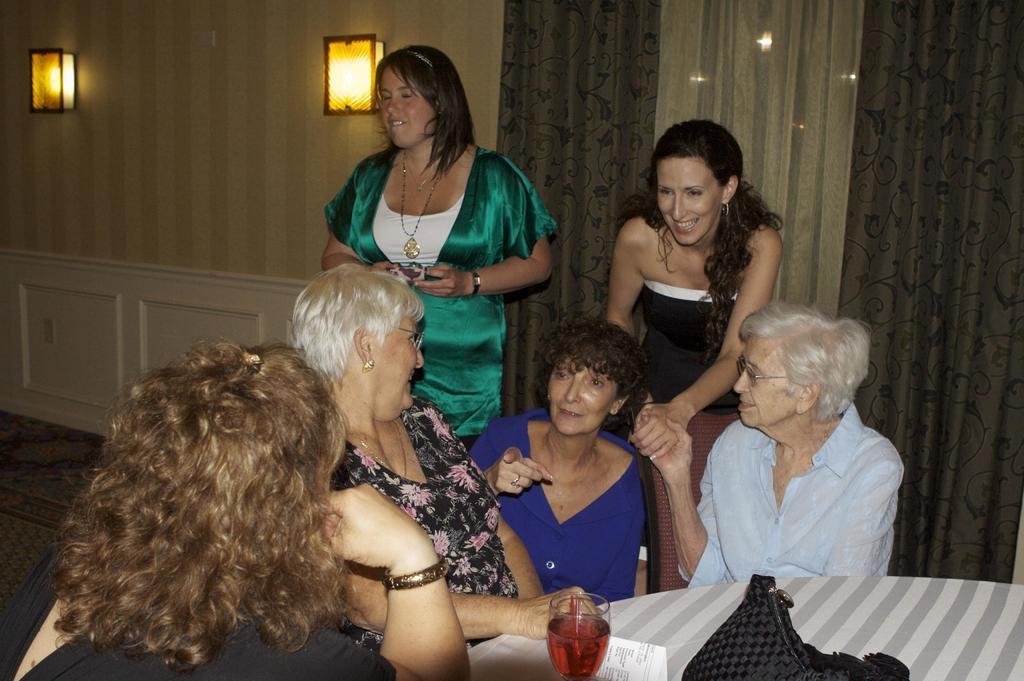Please provide a concise description of this image. This is an inside view. Here I can see four women sitting on the chairs around the table. This table is covered with a cloth on which a glass, bag and a paper are placed. At the back two women are standing. In the background there is a wall on which two lights are attached. On the right side there is a curtain. 